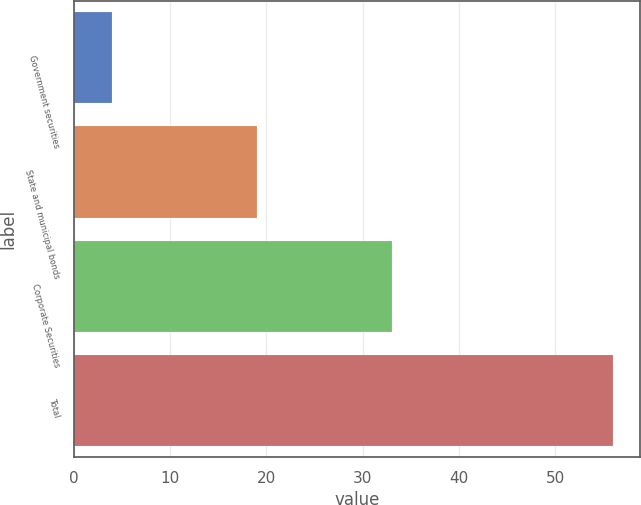Convert chart to OTSL. <chart><loc_0><loc_0><loc_500><loc_500><bar_chart><fcel>Government securities<fcel>State and municipal bonds<fcel>Corporate Securities<fcel>Total<nl><fcel>4<fcel>19<fcel>33<fcel>56<nl></chart> 